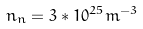<formula> <loc_0><loc_0><loc_500><loc_500>n _ { n } = 3 * 1 0 ^ { 2 5 } m ^ { - 3 }</formula> 